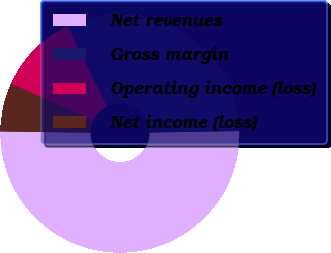<chart> <loc_0><loc_0><loc_500><loc_500><pie_chart><fcel>Net revenues<fcel>Gross margin<fcel>Operating income (loss)<fcel>Net income (loss)<nl><fcel>50.46%<fcel>31.98%<fcel>10.97%<fcel>6.58%<nl></chart> 